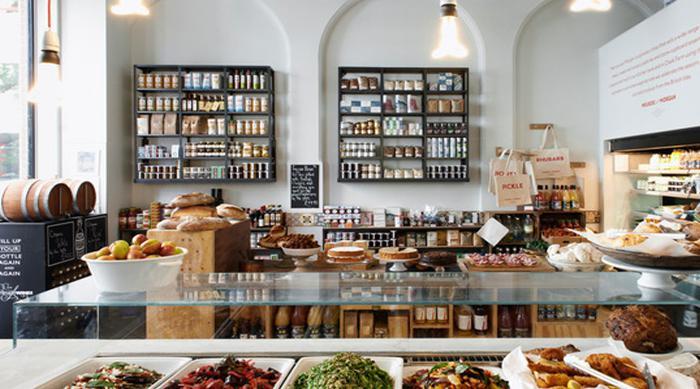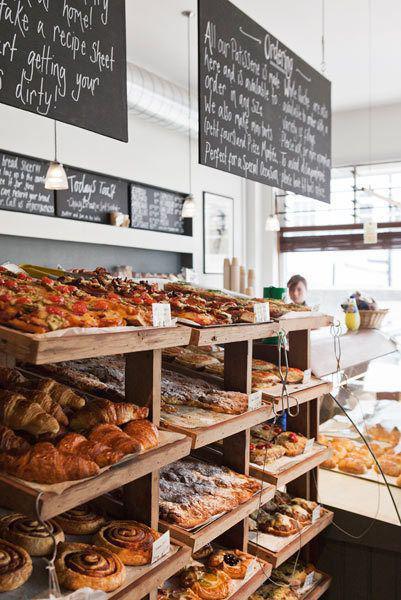The first image is the image on the left, the second image is the image on the right. Considering the images on both sides, is "there is a person in one of the images" valid? Answer yes or no. Yes. The first image is the image on the left, the second image is the image on the right. Considering the images on both sides, is "At least one person's head can be seen in one of the images." valid? Answer yes or no. Yes. The first image is the image on the left, the second image is the image on the right. Considering the images on both sides, is "Product information is written in white on black signs in at least one image." valid? Answer yes or no. Yes. 